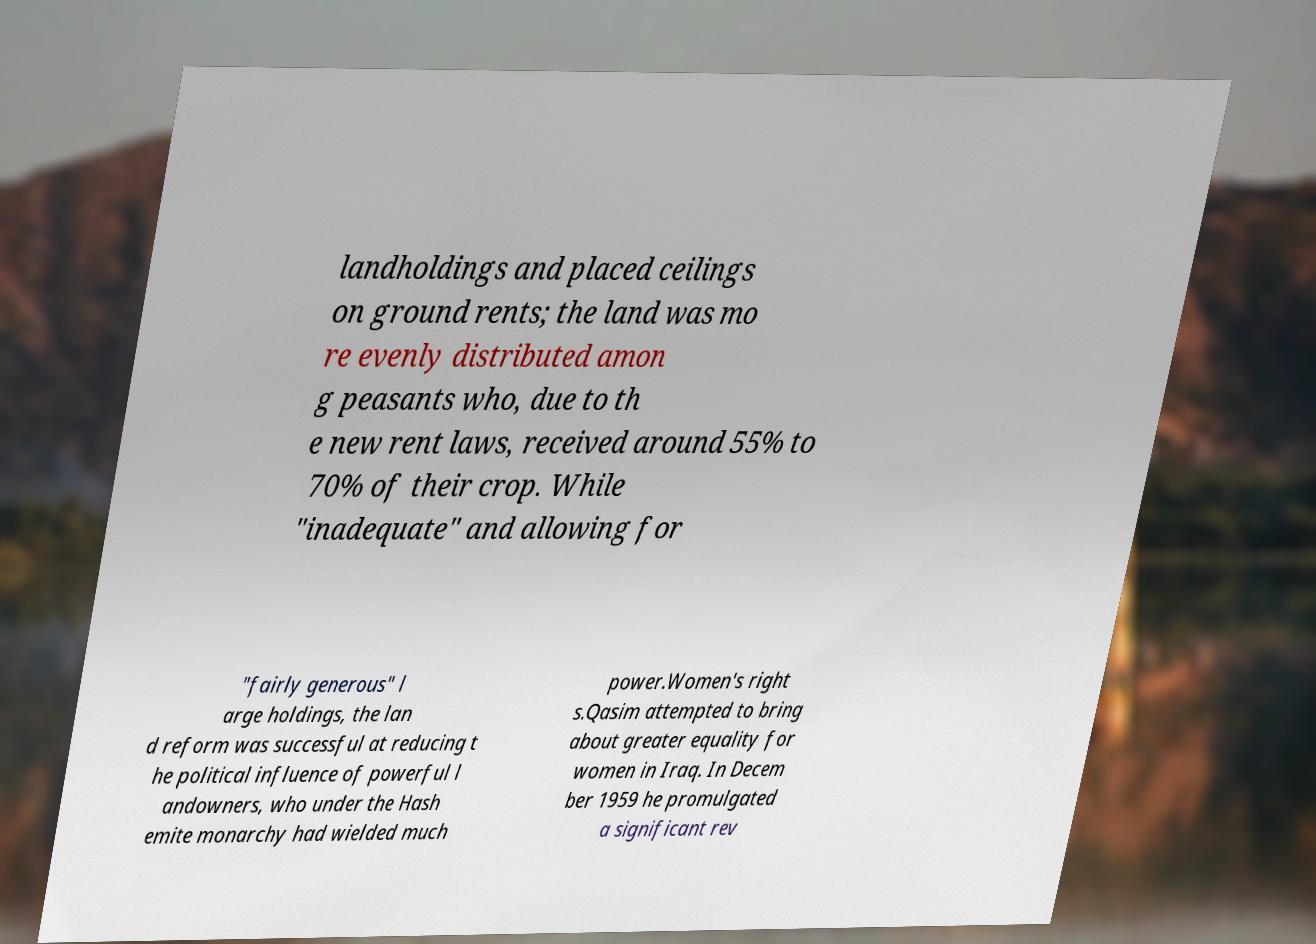There's text embedded in this image that I need extracted. Can you transcribe it verbatim? landholdings and placed ceilings on ground rents; the land was mo re evenly distributed amon g peasants who, due to th e new rent laws, received around 55% to 70% of their crop. While "inadequate" and allowing for "fairly generous" l arge holdings, the lan d reform was successful at reducing t he political influence of powerful l andowners, who under the Hash emite monarchy had wielded much power.Women's right s.Qasim attempted to bring about greater equality for women in Iraq. In Decem ber 1959 he promulgated a significant rev 